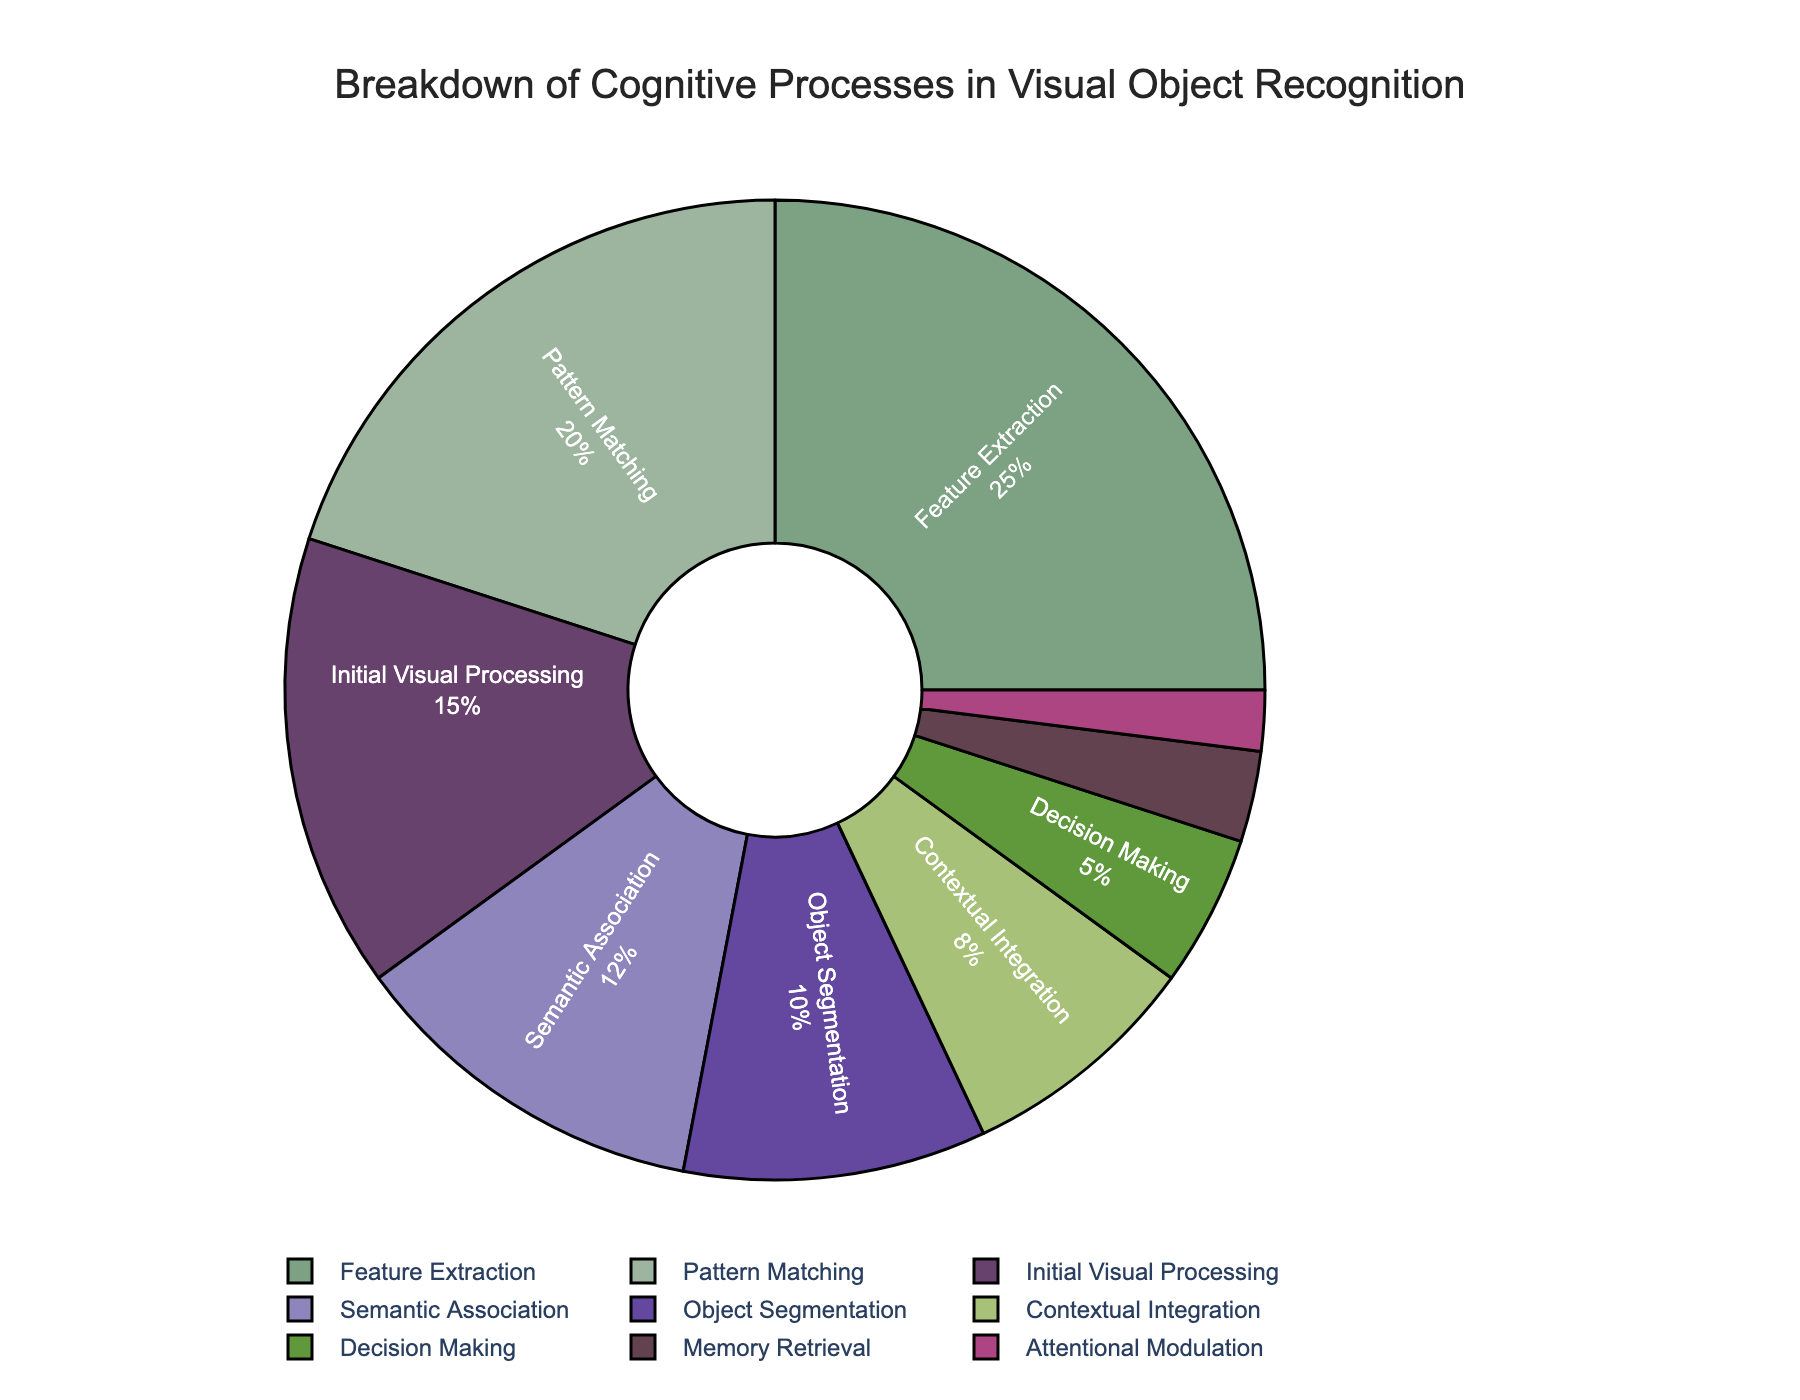What is the most time-consuming cognitive process during visual object recognition? The pie chart visually shows that "Feature Extraction" occupies the largest segment of the pie chart.
Answer: Feature Extraction Which cognitive process takes up the least amount of time? By looking at the smallest segment of the pie chart, "Attentional Modulation" is identified as the least time-consuming process.
Answer: Attentional Modulation Compare the combined time percentage spent on "Initial Visual Processing" and "Feature Extraction" with the "Pattern Matching" process. Which is higher? Adding the percentages of "Initial Visual Processing" (15%) and "Feature Extraction" (25%), we get 40%. "Pattern Matching" alone is 20%. Hence 40% is higher than 20%.
Answer: Initial Visual Processing and Feature Extraction Is "Semantic Association" more time-consuming than "Contextual Integration"? "Semantic Association" has a larger segment in the pie chart, representing 12%, while "Contextual Integration" is 8%, indicating that "Semantic Association" takes more time.
Answer: Yes What's the total percentage of time spent on processes responsible for integrating higher-order information, such as "Semantic Association", "Contextual Integration", and "Decision Making"? Summing up "Semantic Association" (12%), "Contextual Integration" (8%), and "Decision Making" (5%) yields a total of 25%.
Answer: 25% Which segment is represented in a shade of green? The specific shade of green used in the segment is representative of "Contextual Integration".
Answer: Contextual Integration What is the combined time percentage for "Memory Retrieval" and "Attentional Modulation"? Adding "Memory Retrieval" (3%) and "Attentional Modulation" (2%) results in a total of 5%.
Answer: 5% Which cognitive process takes more time: "Object Segmentation" or "Memory Retrieval"? Comparing the two segments, "Object Segmentation" has a time percentage of 10%, while "Memory Retrieval" has 3%, so "Object Segmentation" takes more time.
Answer: Object Segmentation 